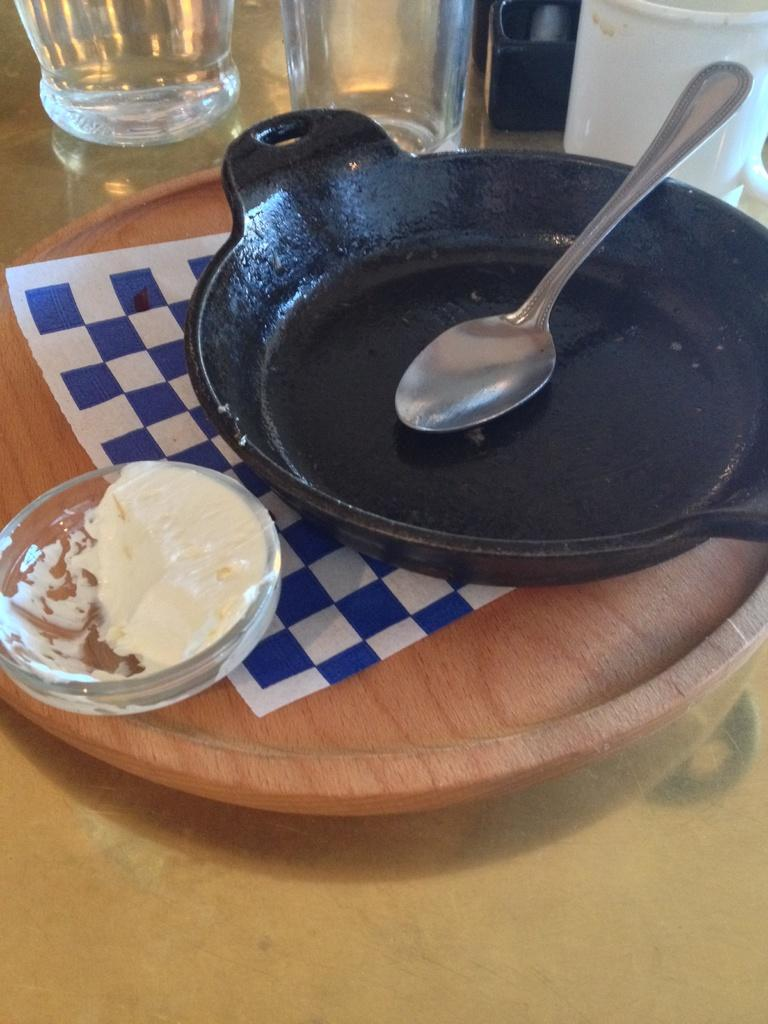What type of furniture is in the image? There is a table in the image. What is placed on the table? A wooden object, a pan, a spoon, glasses, and other food items are present on the table. Can you describe the wooden object on the table? Unfortunately, the facts provided do not give a detailed description of the wooden object. How many glasses are on the table? The number of glasses on the table is not specified in the facts. What type of glue is being used to hold the mine in the image? There is no mention of glue or a mine in the image. The image features a table with various objects, including a wooden object, a pan, a spoon, glasses, and other food items. 